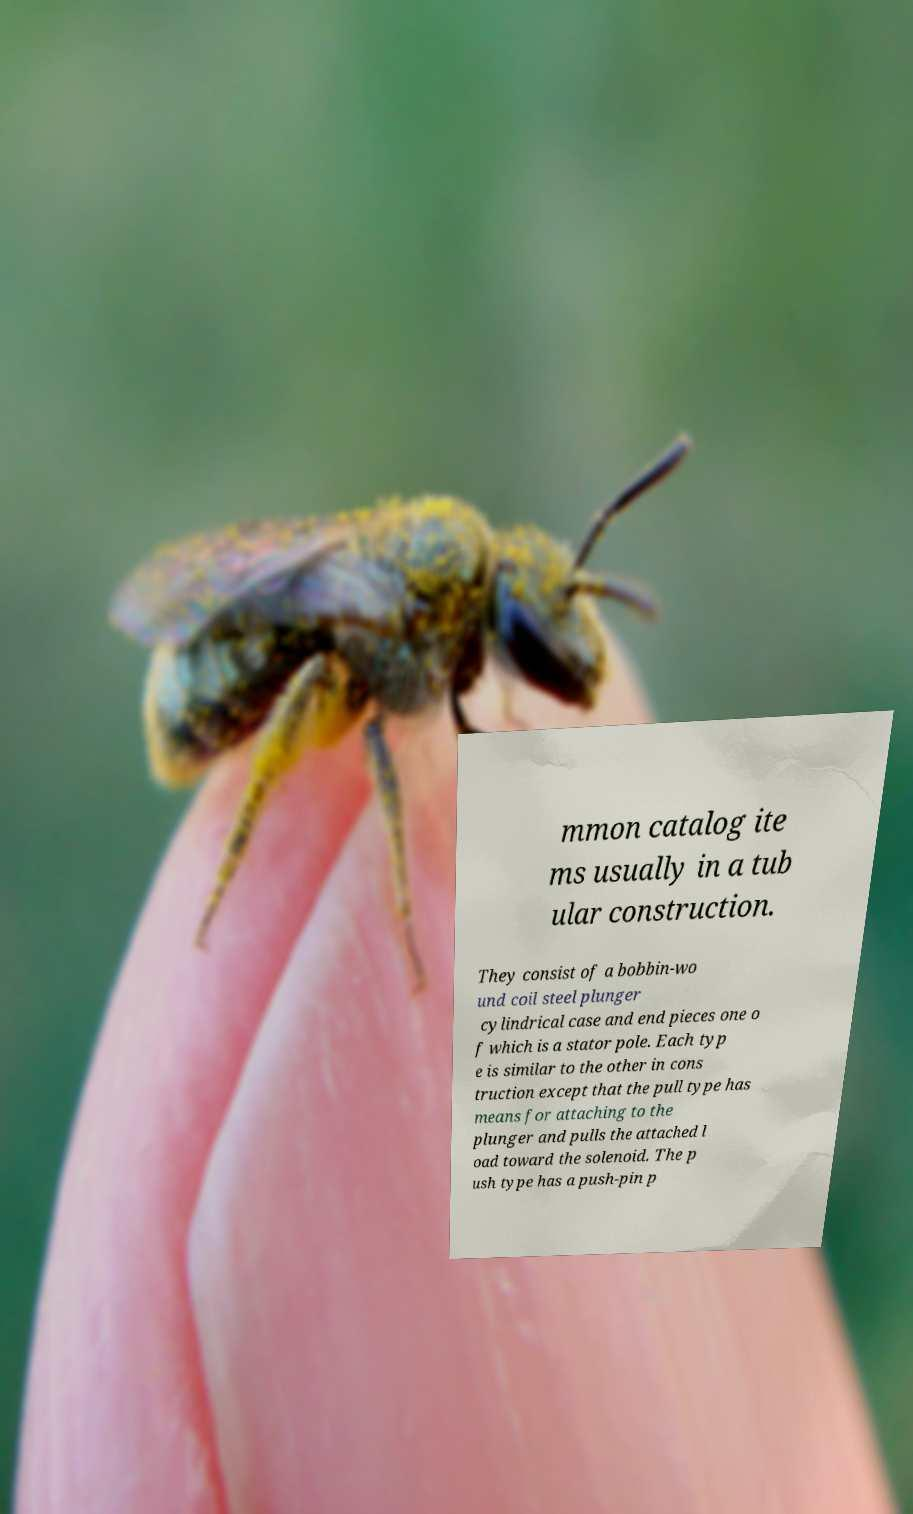Could you assist in decoding the text presented in this image and type it out clearly? mmon catalog ite ms usually in a tub ular construction. They consist of a bobbin-wo und coil steel plunger cylindrical case and end pieces one o f which is a stator pole. Each typ e is similar to the other in cons truction except that the pull type has means for attaching to the plunger and pulls the attached l oad toward the solenoid. The p ush type has a push-pin p 